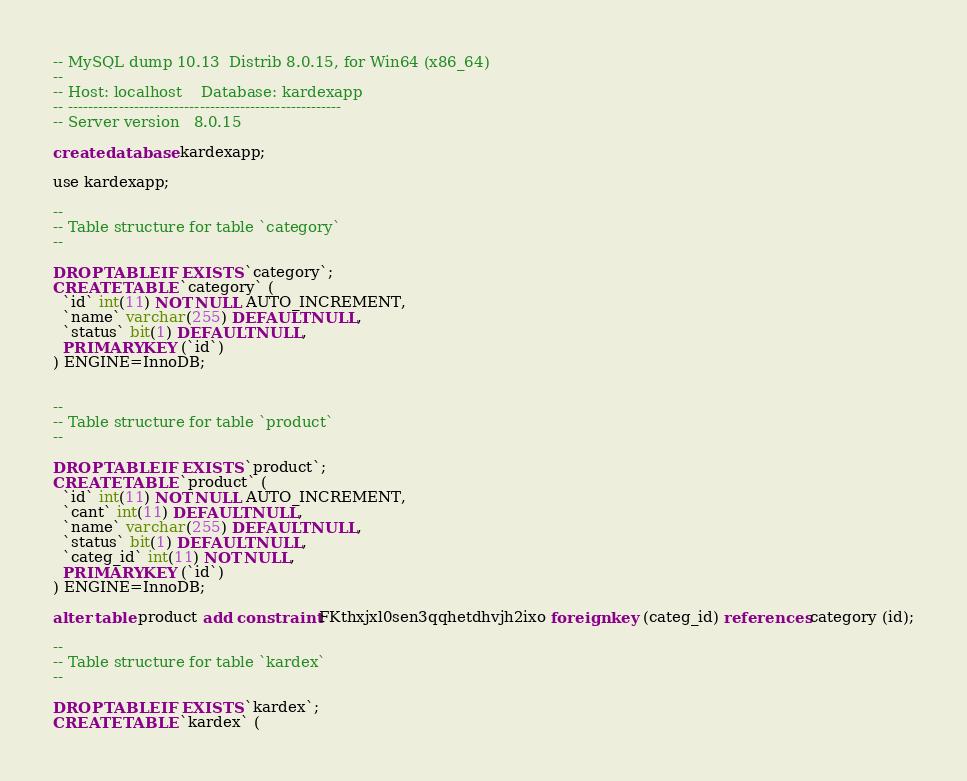<code> <loc_0><loc_0><loc_500><loc_500><_SQL_>-- MySQL dump 10.13  Distrib 8.0.15, for Win64 (x86_64)
--
-- Host: localhost    Database: kardexapp
-- ------------------------------------------------------
-- Server version	8.0.15

create database kardexapp;

use kardexapp;

--
-- Table structure for table `category`
--

DROP TABLE IF EXISTS `category`;
CREATE TABLE `category` (
  `id` int(11) NOT NULL AUTO_INCREMENT,
  `name` varchar(255) DEFAULT NULL,
  `status` bit(1) DEFAULT NULL,
  PRIMARY KEY (`id`)
) ENGINE=InnoDB;


--
-- Table structure for table `product`
--

DROP TABLE IF EXISTS `product`;
CREATE TABLE `product` (
  `id` int(11) NOT NULL AUTO_INCREMENT,
  `cant` int(11) DEFAULT NULL,
  `name` varchar(255) DEFAULT NULL,
  `status` bit(1) DEFAULT NULL,
  `categ_id` int(11) NOT NULL,
  PRIMARY KEY (`id`)
) ENGINE=InnoDB;

alter table product add constraint FKthxjxl0sen3qqhetdhvjh2ixo foreign key (categ_id) references category (id);

--
-- Table structure for table `kardex`
--

DROP TABLE IF EXISTS `kardex`;
CREATE TABLE `kardex` (</code> 